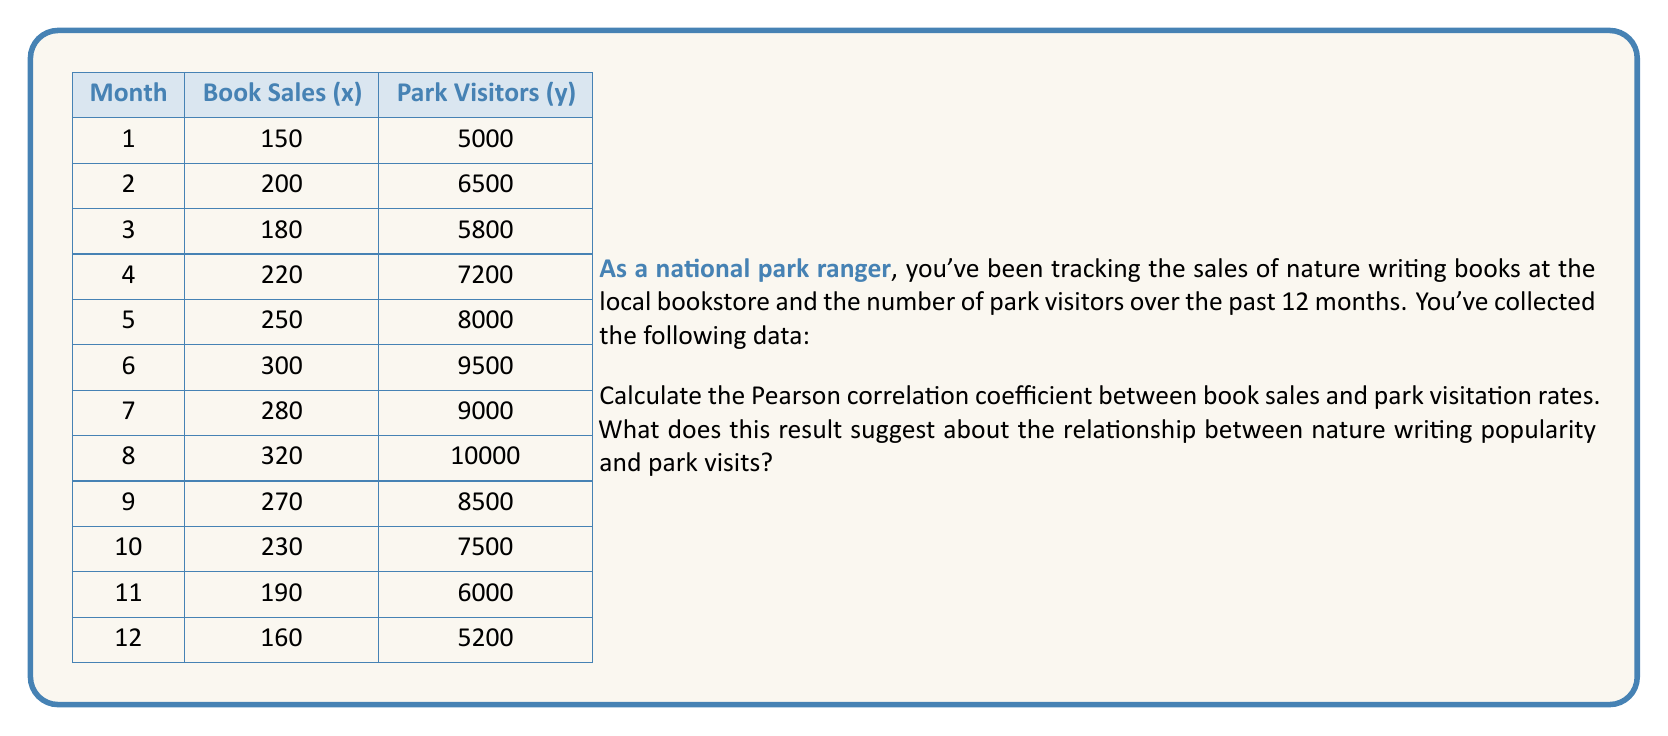Teach me how to tackle this problem. To calculate the Pearson correlation coefficient (r), we'll use the formula:

$$ r = \frac{\sum_{i=1}^{n} (x_i - \bar{x})(y_i - \bar{y})}{\sqrt{\sum_{i=1}^{n} (x_i - \bar{x})^2 \sum_{i=1}^{n} (y_i - \bar{y})^2}} $$

Where:
$x_i$ and $y_i$ are the individual sample points
$\bar{x}$ and $\bar{y}$ are the sample means

Step 1: Calculate the means
$\bar{x} = \frac{2750}{12} = 229.17$
$\bar{y} = \frac{88200}{12} = 7350$

Step 2: Calculate the required sums
$\sum_{i=1}^{n} (x_i - \bar{x})(y_i - \bar{y}) = 684,291.67$
$\sum_{i=1}^{n} (x_i - \bar{x})^2 = 52,552.08$
$\sum_{i=1}^{n} (y_i - \bar{y})^2 = 46,575,000$

Step 3: Apply the formula
$$ r = \frac{684,291.67}{\sqrt{52,552.08 \times 46,575,000}} = 0.9865 $$

The Pearson correlation coefficient is approximately 0.9865.
Answer: The Pearson correlation coefficient is 0.9865, indicating a very strong positive correlation between nature writing book sales and park visitation rates. This suggests that as the popularity of nature writing increases (as measured by book sales), there is a corresponding increase in park visits, or vice versa. However, it's important to note that correlation does not imply causation, and other factors may be influencing both variables. 